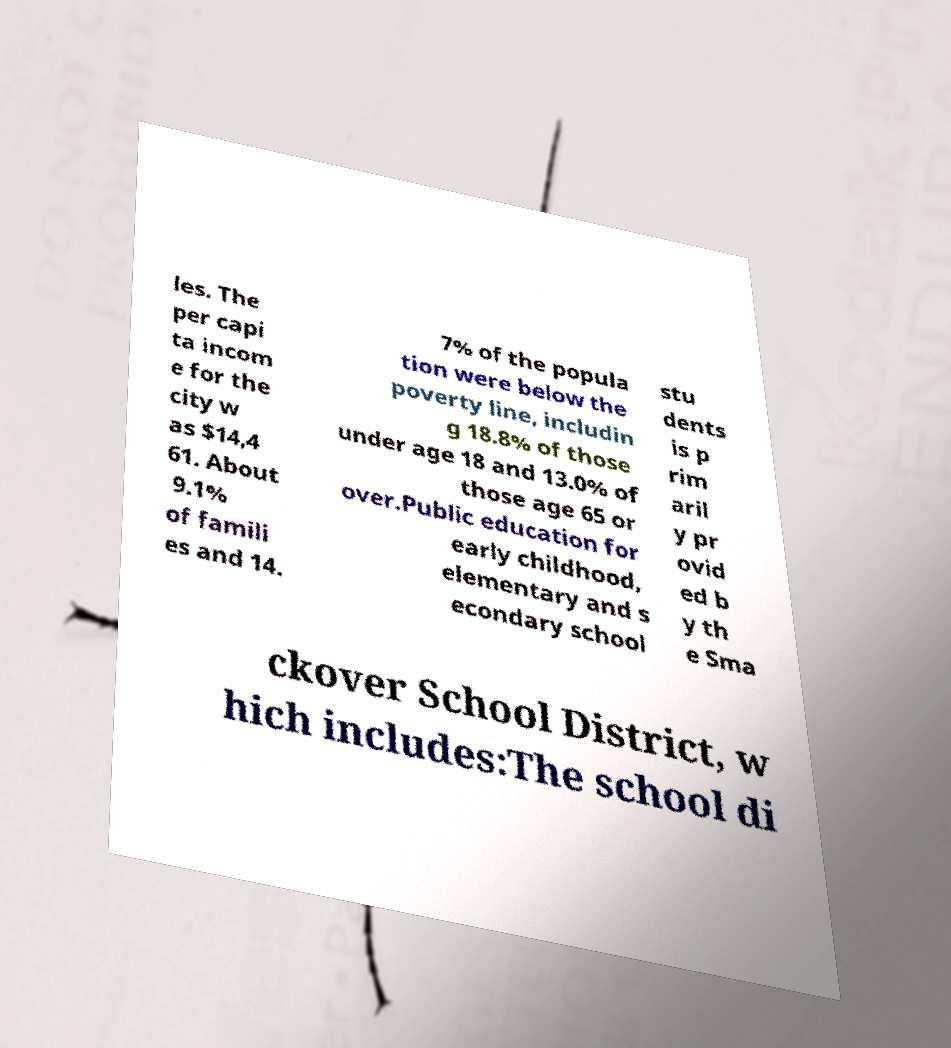What messages or text are displayed in this image? I need them in a readable, typed format. les. The per capi ta incom e for the city w as $14,4 61. About 9.1% of famili es and 14. 7% of the popula tion were below the poverty line, includin g 18.8% of those under age 18 and 13.0% of those age 65 or over.Public education for early childhood, elementary and s econdary school stu dents is p rim aril y pr ovid ed b y th e Sma ckover School District, w hich includes:The school di 